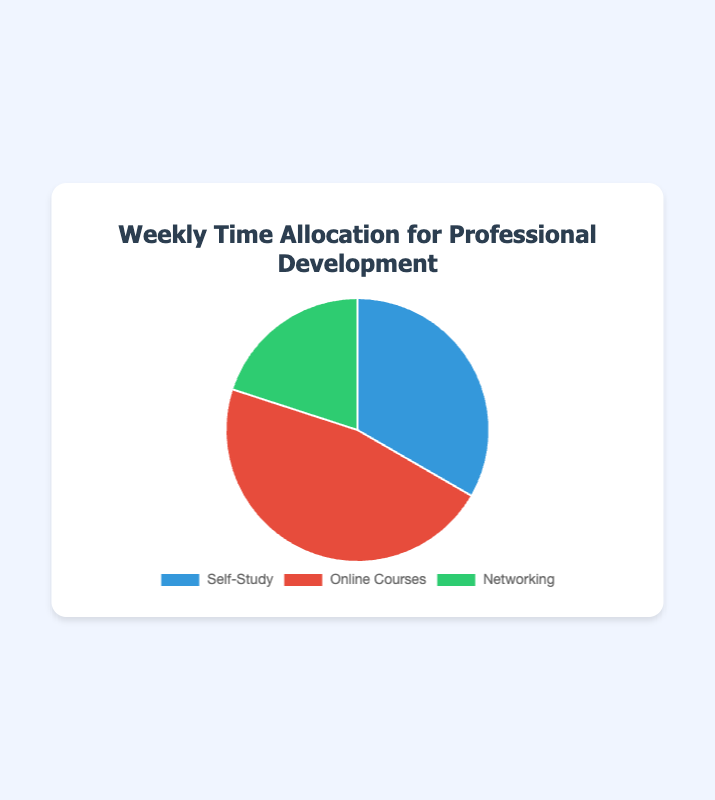What category takes up the largest portion of the weekly time allocation? By looking at the sizes of each segment of the pie chart, it’s clear that the 'Online Courses' section is the largest compared to the 'Self-Study' and 'Networking' sections.
Answer: Online Courses Which category has the smallest time allocation per week? By observing the pie chart segments, the 'Networking' category has the smallest segment, indicating it has the least number of hours allocated per week.
Answer: Networking How many more hours per week are spent on Online Courses compared to Networking? The pie chart shows 7 hours per week allocated to Online Courses and 3 hours per week allocated to Networking. The difference is 7 - 3 = 4 hours.
Answer: 4 hours What is the total number of hours spent per week on professional development activities? Adding the hours allocated to Self-Study, Online Courses, and Networking provides the total hours: 5 + 7 + 3 = 15 hours.
Answer: 15 hours How do the hours allocated to Self-Study compare to the hours allocated to Networking? By comparing the segments in the pie chart, Self-Study (5 hours) is larger than Networking (3 hours). The difference is 5 - 3 = 2 hours.
Answer: Self-Study is larger by 2 hours What percentage of the total weekly time allocation is spent on Self-Study? The total hours per week are 15. Self-Study is allocated 5 hours. The percentage is calculated as (5/15) * 100 = 33.33%.
Answer: 33.33% Is the time spent on Self-Study greater than half of the time spent on Online Courses? Half of the time spent on Online Courses is 7 / 2 = 3.5 hours. Since 5 hours are spent on Self-Study, which is greater than 3.5 hours, the answer is yes.
Answer: Yes How does the total time spent on Self-Study and Networking compare to the time spent on Online Courses? Adding the hours for Self-Study and Networking gives 5 + 3 = 8 hours. Comparing this to 7 hours for Online Courses, 8 is greater than 7.
Answer: Self-Study and Networking together are greater What is the ratio of time spent on Self-Study to the time spent on Networking? The pie chart shows 5 hours for Self-Study and 3 hours for Networking. The ratio is 5:3.
Answer: 5:3 What visual color corresponds to Online Courses in the pie chart? By examining the pie chart, the color corresponding to Online Courses is red.
Answer: Red 